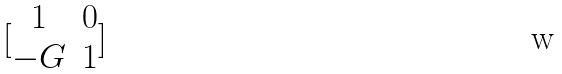<formula> <loc_0><loc_0><loc_500><loc_500>[ \begin{matrix} 1 & 0 \\ - G & 1 \end{matrix} ]</formula> 